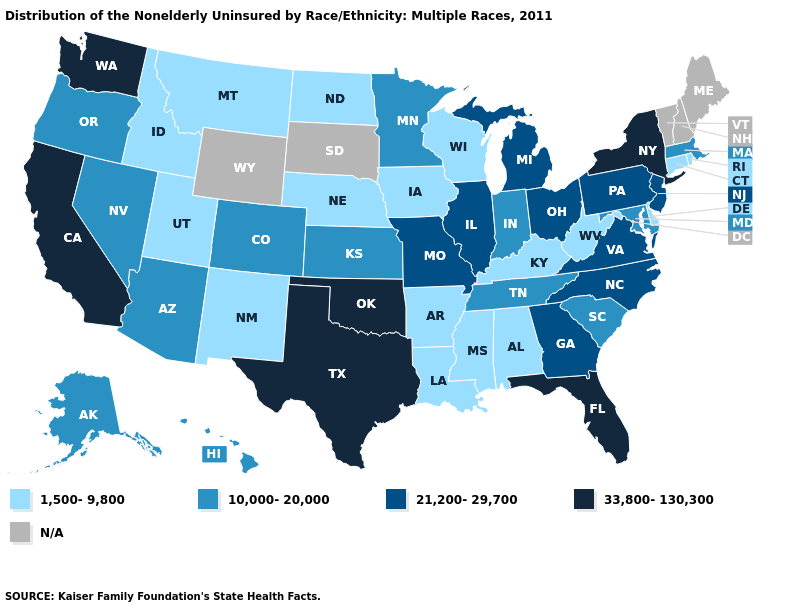What is the value of South Carolina?
Concise answer only. 10,000-20,000. What is the lowest value in the USA?
Answer briefly. 1,500-9,800. Name the states that have a value in the range 1,500-9,800?
Keep it brief. Alabama, Arkansas, Connecticut, Delaware, Idaho, Iowa, Kentucky, Louisiana, Mississippi, Montana, Nebraska, New Mexico, North Dakota, Rhode Island, Utah, West Virginia, Wisconsin. What is the value of Montana?
Write a very short answer. 1,500-9,800. Does North Dakota have the lowest value in the MidWest?
Concise answer only. Yes. What is the value of New York?
Concise answer only. 33,800-130,300. Does the first symbol in the legend represent the smallest category?
Give a very brief answer. Yes. Does Ohio have the highest value in the USA?
Write a very short answer. No. Does Nevada have the highest value in the USA?
Be succinct. No. Among the states that border Colorado , does Oklahoma have the highest value?
Be succinct. Yes. What is the highest value in the MidWest ?
Keep it brief. 21,200-29,700. What is the highest value in the USA?
Answer briefly. 33,800-130,300. Name the states that have a value in the range N/A?
Quick response, please. Maine, New Hampshire, South Dakota, Vermont, Wyoming. Which states have the lowest value in the West?
Give a very brief answer. Idaho, Montana, New Mexico, Utah. 